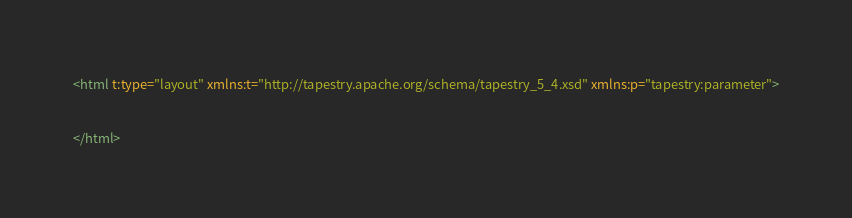<code> <loc_0><loc_0><loc_500><loc_500><_XML_><html t:type="layout" xmlns:t="http://tapestry.apache.org/schema/tapestry_5_4.xsd" xmlns:p="tapestry:parameter">


</html></code> 